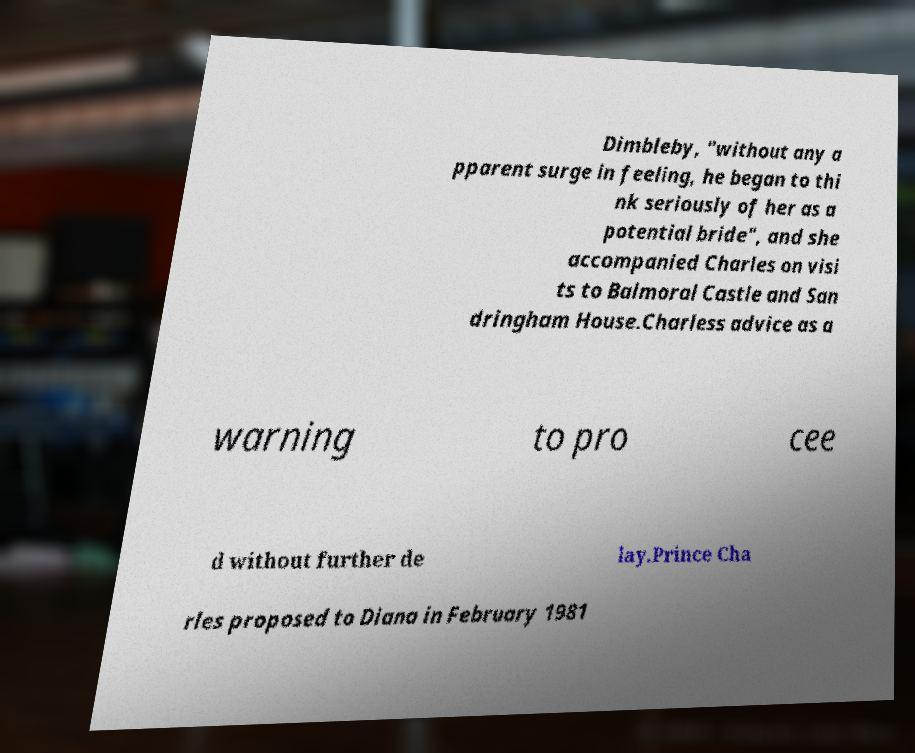Can you accurately transcribe the text from the provided image for me? Dimbleby, "without any a pparent surge in feeling, he began to thi nk seriously of her as a potential bride", and she accompanied Charles on visi ts to Balmoral Castle and San dringham House.Charless advice as a warning to pro cee d without further de lay.Prince Cha rles proposed to Diana in February 1981 